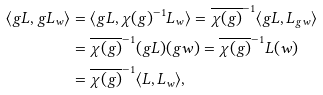<formula> <loc_0><loc_0><loc_500><loc_500>\langle g L , g L _ { w } \rangle & = \langle g L , \chi ( g ) ^ { - 1 } L _ { w } \rangle = \overline { \chi ( g ) } ^ { - 1 } \langle g L , L _ { g w } \rangle \\ & = \overline { \chi ( g ) } ^ { - 1 } ( g L ) ( g w ) = \overline { \chi ( g ) } ^ { - 1 } L ( w ) \\ & = \overline { \chi ( g ) } ^ { - 1 } \langle L , L _ { w } \rangle ,</formula> 